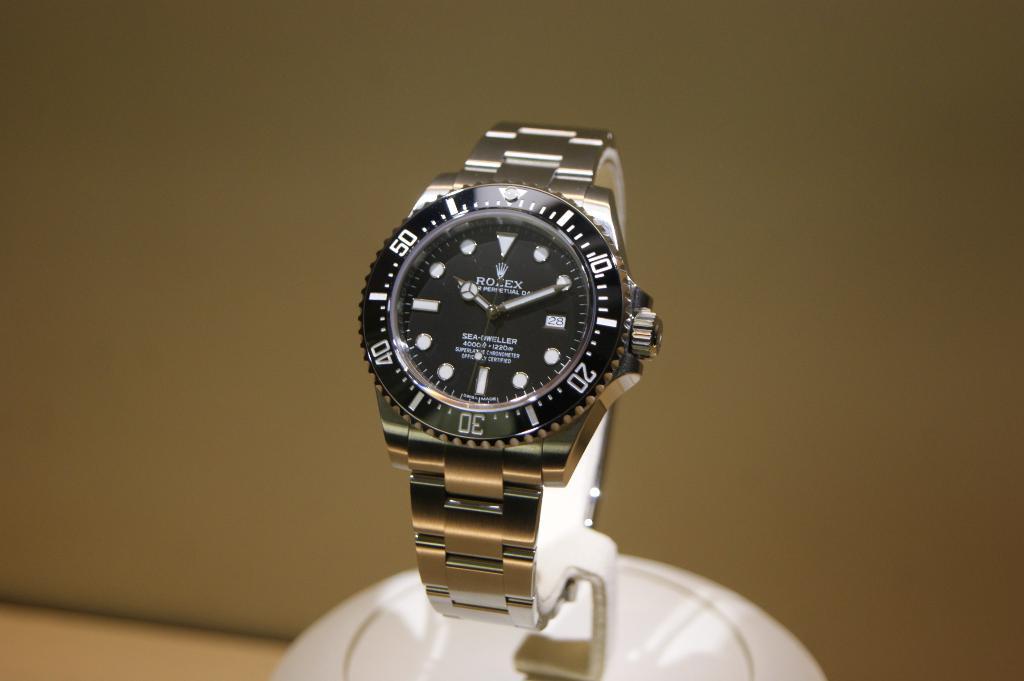Who makes the watch?
Provide a succinct answer. Rolex. 